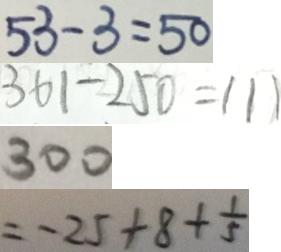<formula> <loc_0><loc_0><loc_500><loc_500>5 3 - 3 = 5 0 
 3 6 1 - 2 5 0 = 1 1 1 
 3 0 0 
 = - 2 5 + 8 + \frac { 1 } { 5 }</formula> 